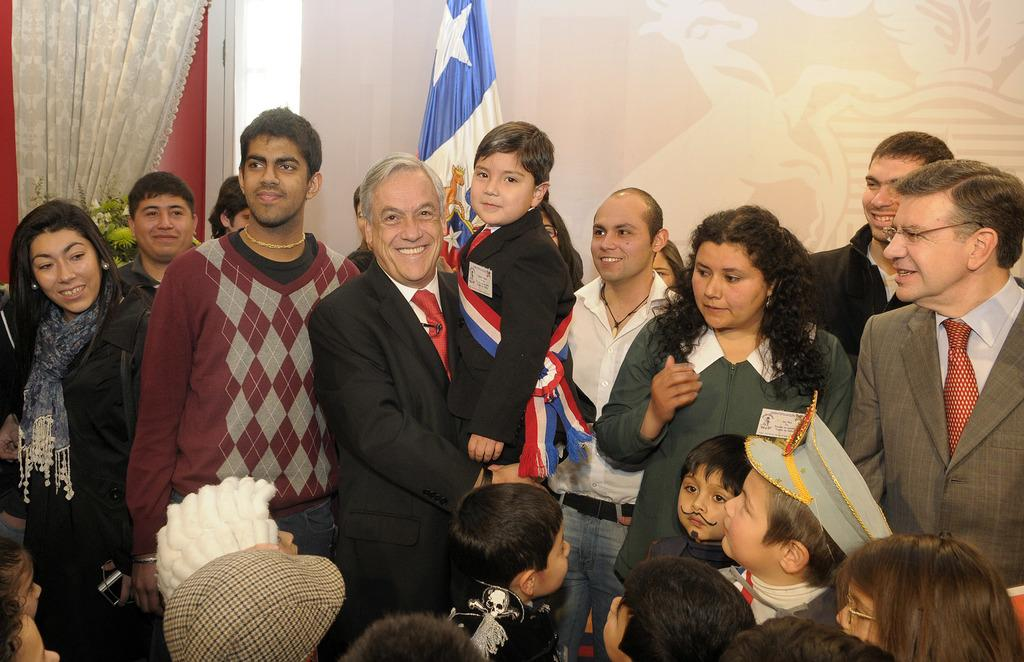How many people are in the image? There is a group of people in the image, but the exact number cannot be determined from the provided facts. What can be seen in the background of the image? In the background of the image, there is a flag, a curtain, a plant, and a wall. Can you describe the plant in the image? The facts do not provide enough information to describe the plant in the image. What type of metal vest is the person in the image wearing? There is: There is no person wearing a vest, metal or otherwise, in the image. 